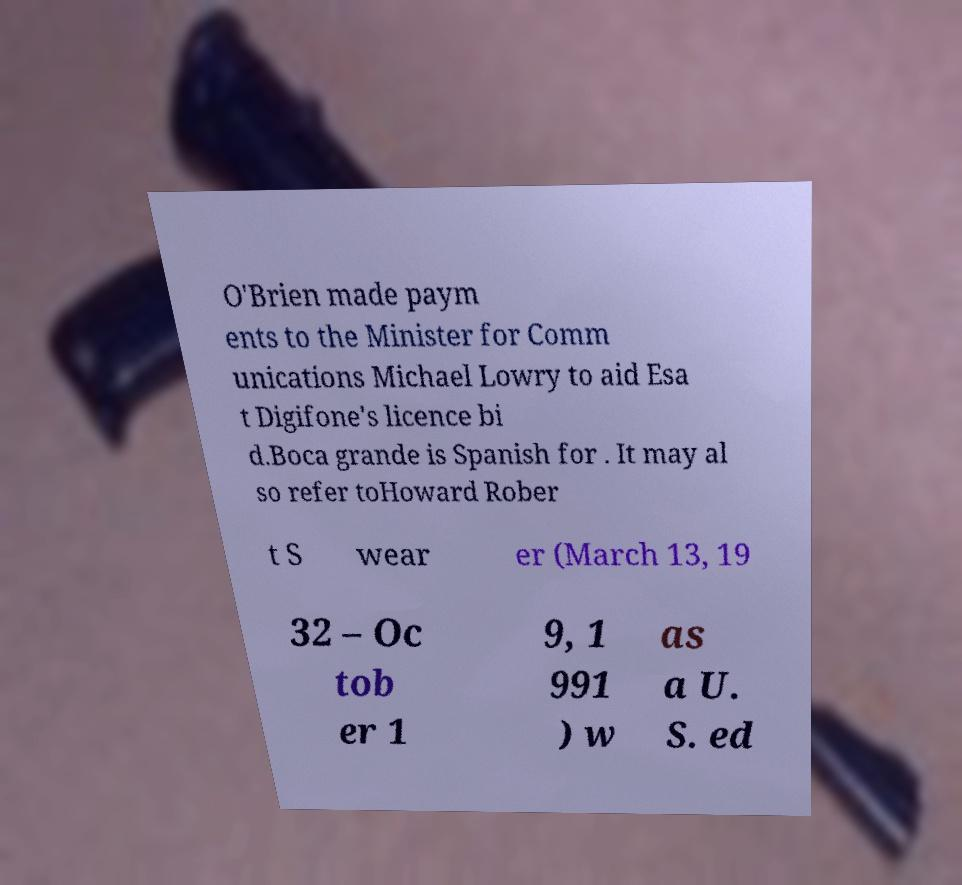Can you read and provide the text displayed in the image?This photo seems to have some interesting text. Can you extract and type it out for me? O'Brien made paym ents to the Minister for Comm unications Michael Lowry to aid Esa t Digifone's licence bi d.Boca grande is Spanish for . It may al so refer toHoward Rober t S wear er (March 13, 19 32 – Oc tob er 1 9, 1 991 ) w as a U. S. ed 